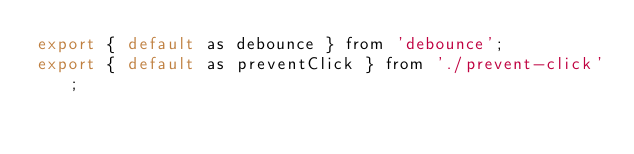Convert code to text. <code><loc_0><loc_0><loc_500><loc_500><_JavaScript_>export { default as debounce } from 'debounce';
export { default as preventClick } from './prevent-click';
</code> 